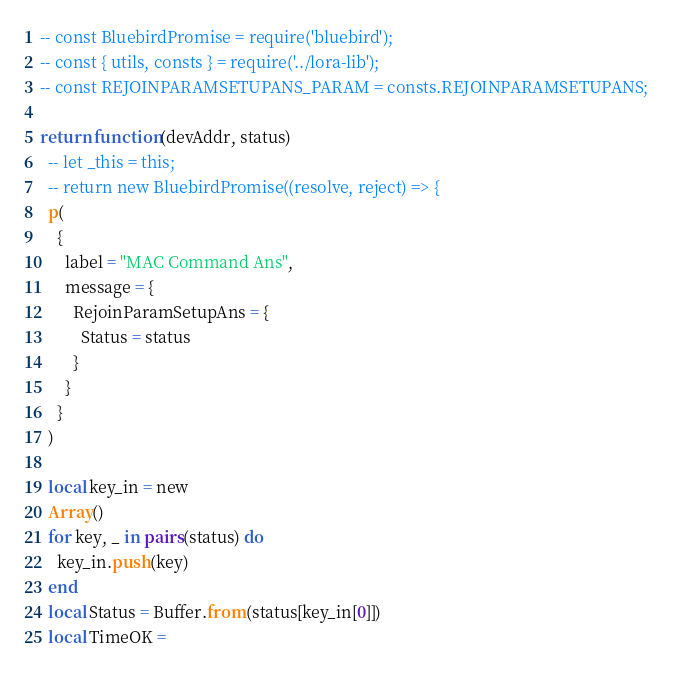<code> <loc_0><loc_0><loc_500><loc_500><_Lua_>-- const BluebirdPromise = require('bluebird');
-- const { utils, consts } = require('../lora-lib');
-- const REJOINPARAMSETUPANS_PARAM = consts.REJOINPARAMSETUPANS;

return function(devAddr, status)
  -- let _this = this;
  -- return new BluebirdPromise((resolve, reject) => {
  p(
    {
      label = "MAC Command Ans",
      message = {
        RejoinParamSetupAns = {
          Status = status
        }
      }
    }
  )

  local key_in = new
  Array()
  for key, _ in pairs(status) do
    key_in.push(key)
  end
  local Status = Buffer.from(status[key_in[0]])
  local TimeOK =</code> 